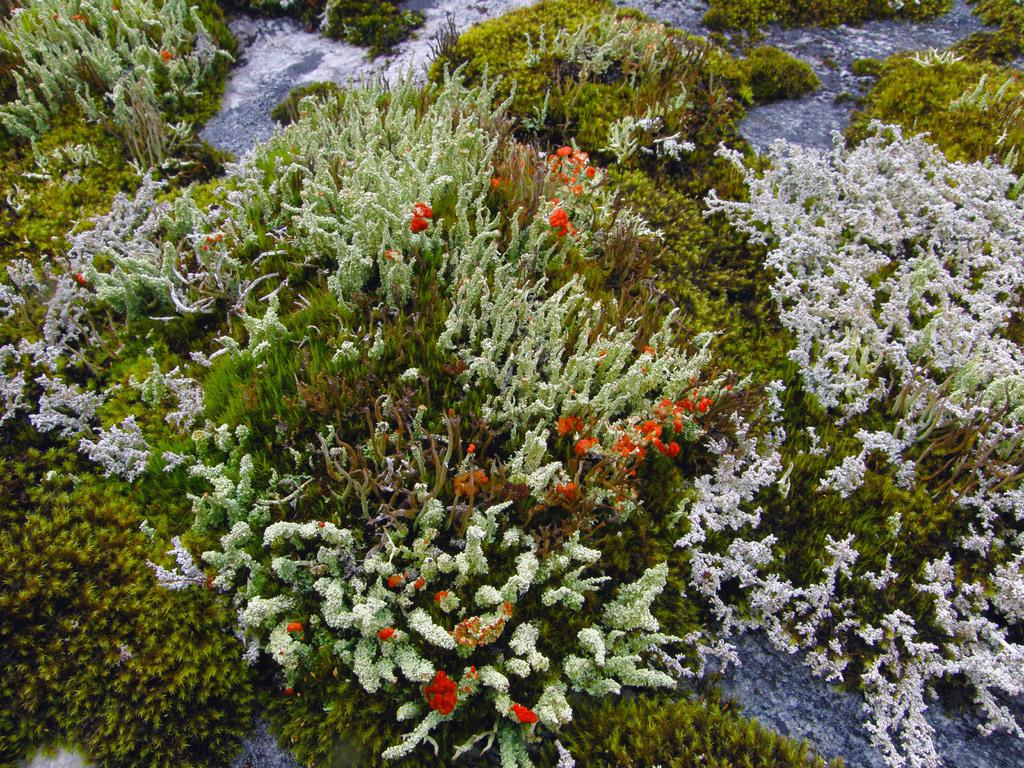What type of living organisms can be seen in the image? Plants can be seen in the image. Can you describe the plants in the image? The plants are in different colors. What nation is represented by the plants in the image? The image does not represent any nation; it simply shows plants in different colors. 